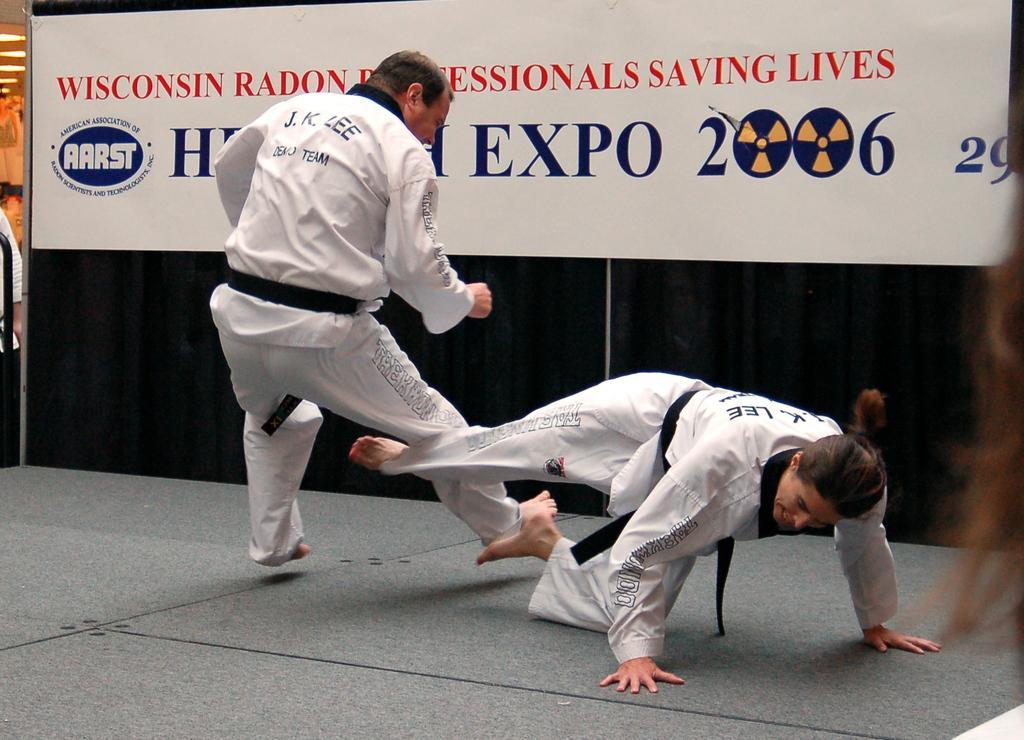Describe this image in one or two sentences. In this picture we can see two men wearing white color shirt and track, playing karate. Behind there is a white and blue color poster banner. 